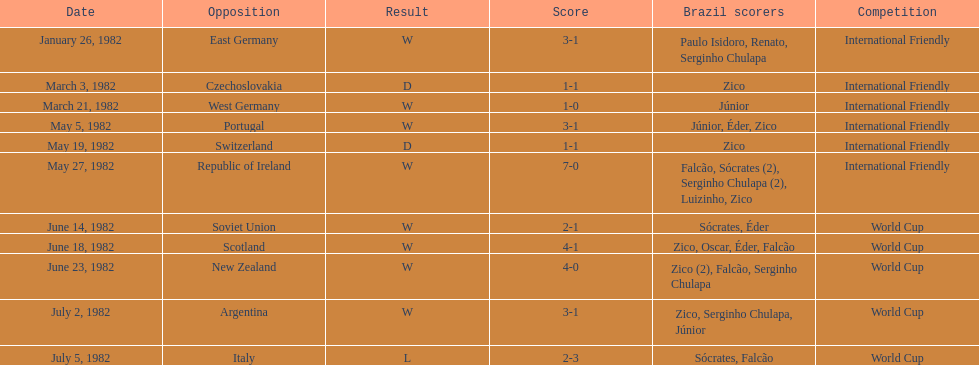What was the total number of losses brazil suffered? 1. 